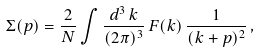<formula> <loc_0><loc_0><loc_500><loc_500>\Sigma ( p ) = \frac { 2 } { N } \int \frac { d ^ { 3 } \, k } { ( 2 \pi ) ^ { 3 } } \, F ( k ) \, \frac { 1 } { ( k + p ) ^ { 2 } } \, ,</formula> 